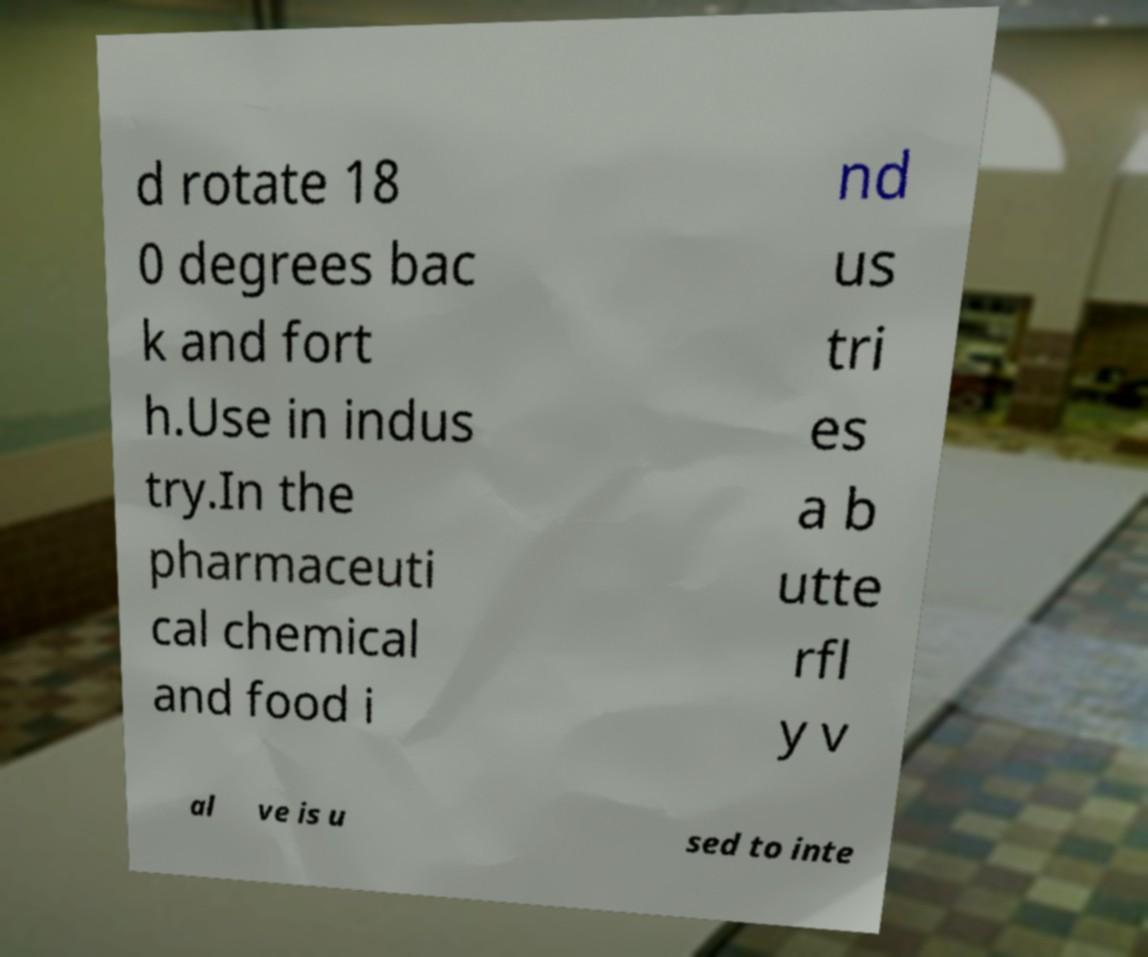Can you accurately transcribe the text from the provided image for me? d rotate 18 0 degrees bac k and fort h.Use in indus try.In the pharmaceuti cal chemical and food i nd us tri es a b utte rfl y v al ve is u sed to inte 